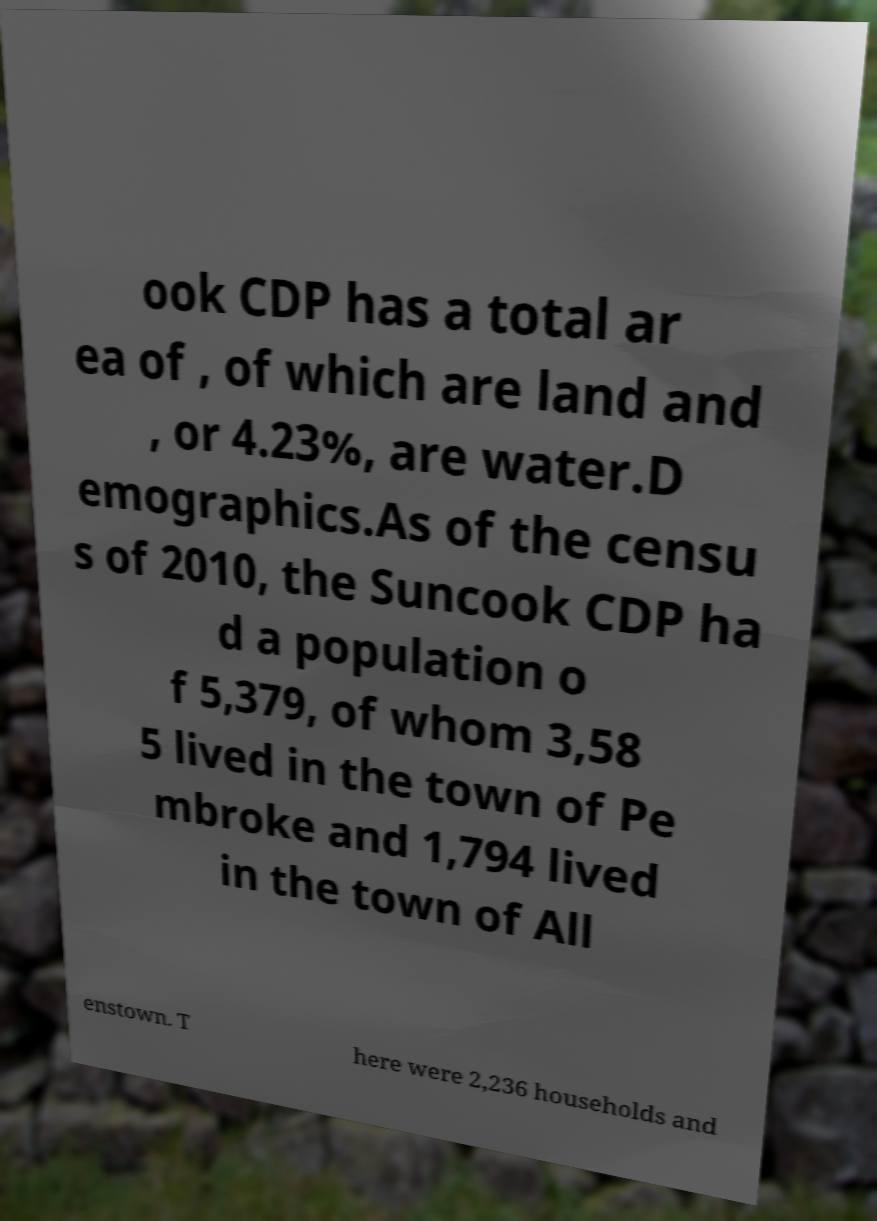Can you accurately transcribe the text from the provided image for me? ook CDP has a total ar ea of , of which are land and , or 4.23%, are water.D emographics.As of the censu s of 2010, the Suncook CDP ha d a population o f 5,379, of whom 3,58 5 lived in the town of Pe mbroke and 1,794 lived in the town of All enstown. T here were 2,236 households and 